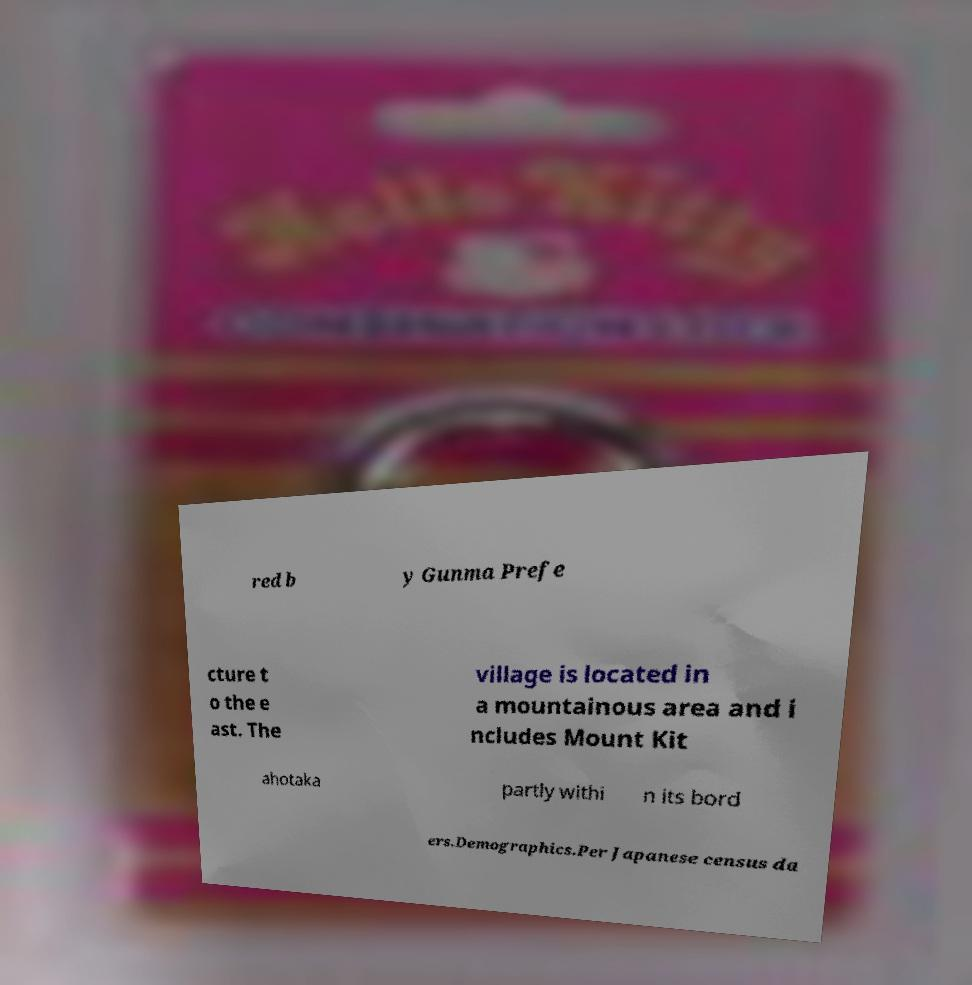I need the written content from this picture converted into text. Can you do that? red b y Gunma Prefe cture t o the e ast. The village is located in a mountainous area and i ncludes Mount Kit ahotaka partly withi n its bord ers.Demographics.Per Japanese census da 